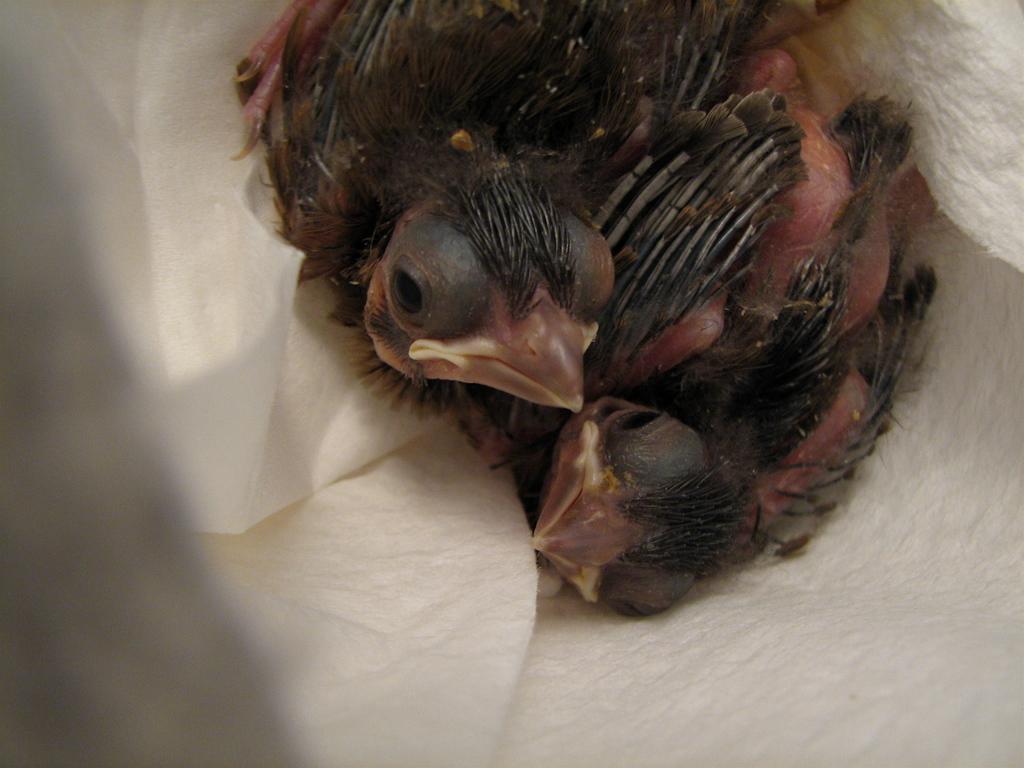In one or two sentences, can you explain what this image depicts? In this image I can see a bird which is in brown color and the bird is on the white color surface. 